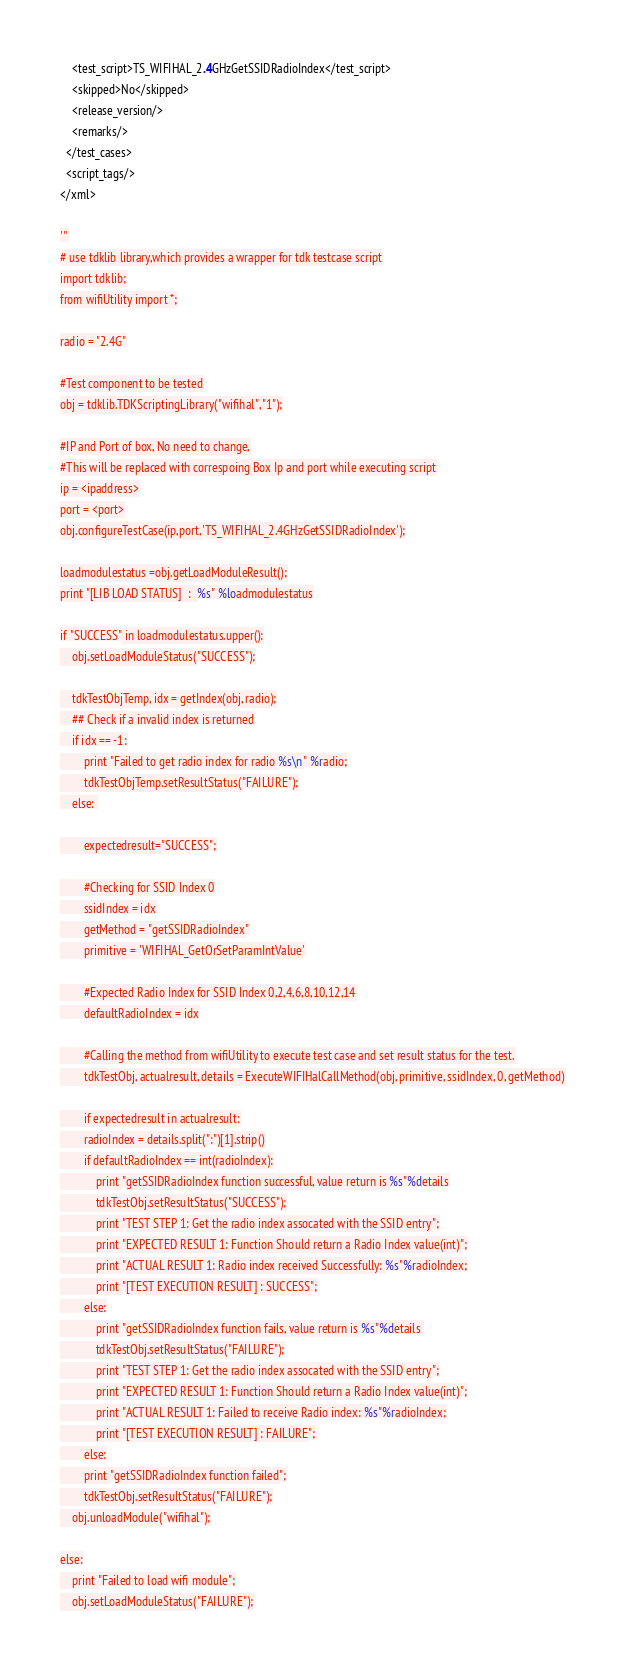<code> <loc_0><loc_0><loc_500><loc_500><_Python_>    <test_script>TS_WIFIHAL_2.4GHzGetSSIDRadioIndex</test_script>
    <skipped>No</skipped>
    <release_version/>
    <remarks/>
  </test_cases>
  <script_tags/>
</xml>

'''
# use tdklib library,which provides a wrapper for tdk testcase script
import tdklib;
from wifiUtility import *;

radio = "2.4G"

#Test component to be tested
obj = tdklib.TDKScriptingLibrary("wifihal","1");

#IP and Port of box, No need to change,
#This will be replaced with correspoing Box Ip and port while executing script
ip = <ipaddress>
port = <port>
obj.configureTestCase(ip,port,'TS_WIFIHAL_2.4GHzGetSSIDRadioIndex');

loadmodulestatus =obj.getLoadModuleResult();
print "[LIB LOAD STATUS]  :  %s" %loadmodulestatus

if "SUCCESS" in loadmodulestatus.upper():
    obj.setLoadModuleStatus("SUCCESS");

    tdkTestObjTemp, idx = getIndex(obj, radio);
    ## Check if a invalid index is returned
    if idx == -1:
        print "Failed to get radio index for radio %s\n" %radio;
        tdkTestObjTemp.setResultStatus("FAILURE");
    else: 

	    expectedresult="SUCCESS";

	    #Checking for SSID Index 0
	    ssidIndex = idx
	    getMethod = "getSSIDRadioIndex"
	    primitive = 'WIFIHAL_GetOrSetParamIntValue'

	    #Expected Radio Index for SSID Index 0,2,4,6,8,10,12,14
	    defaultRadioIndex = idx

	    #Calling the method from wifiUtility to execute test case and set result status for the test.
	    tdkTestObj, actualresult, details = ExecuteWIFIHalCallMethod(obj, primitive, ssidIndex, 0, getMethod)

	    if expectedresult in actualresult:
		radioIndex = details.split(":")[1].strip()
		if defaultRadioIndex == int(radioIndex):
		    print "getSSIDRadioIndex function successful, value return is %s"%details
		    tdkTestObj.setResultStatus("SUCCESS");
		    print "TEST STEP 1: Get the radio index assocated with the SSID entry";
		    print "EXPECTED RESULT 1: Function Should return a Radio Index value(int)";
		    print "ACTUAL RESULT 1: Radio index received Successfully: %s"%radioIndex;
		    print "[TEST EXECUTION RESULT] : SUCCESS";
		else:
		    print "getSSIDRadioIndex function fails, value return is %s"%details 
		    tdkTestObj.setResultStatus("FAILURE");
		    print "TEST STEP 1: Get the radio index assocated with the SSID entry";
		    print "EXPECTED RESULT 1: Function Should return a Radio Index value(int)";
		    print "ACTUAL RESULT 1: Failed to receive Radio index: %s"%radioIndex;
		    print "[TEST EXECUTION RESULT] : FAILURE";
	    else:
		print "getSSIDRadioIndex function failed";
		tdkTestObj.setResultStatus("FAILURE");
    obj.unloadModule("wifihal");

else:
    print "Failed to load wifi module";
    obj.setLoadModuleStatus("FAILURE");
</code> 